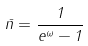<formula> <loc_0><loc_0><loc_500><loc_500>\bar { n } = \frac { 1 } { e ^ { \omega } - 1 }</formula> 